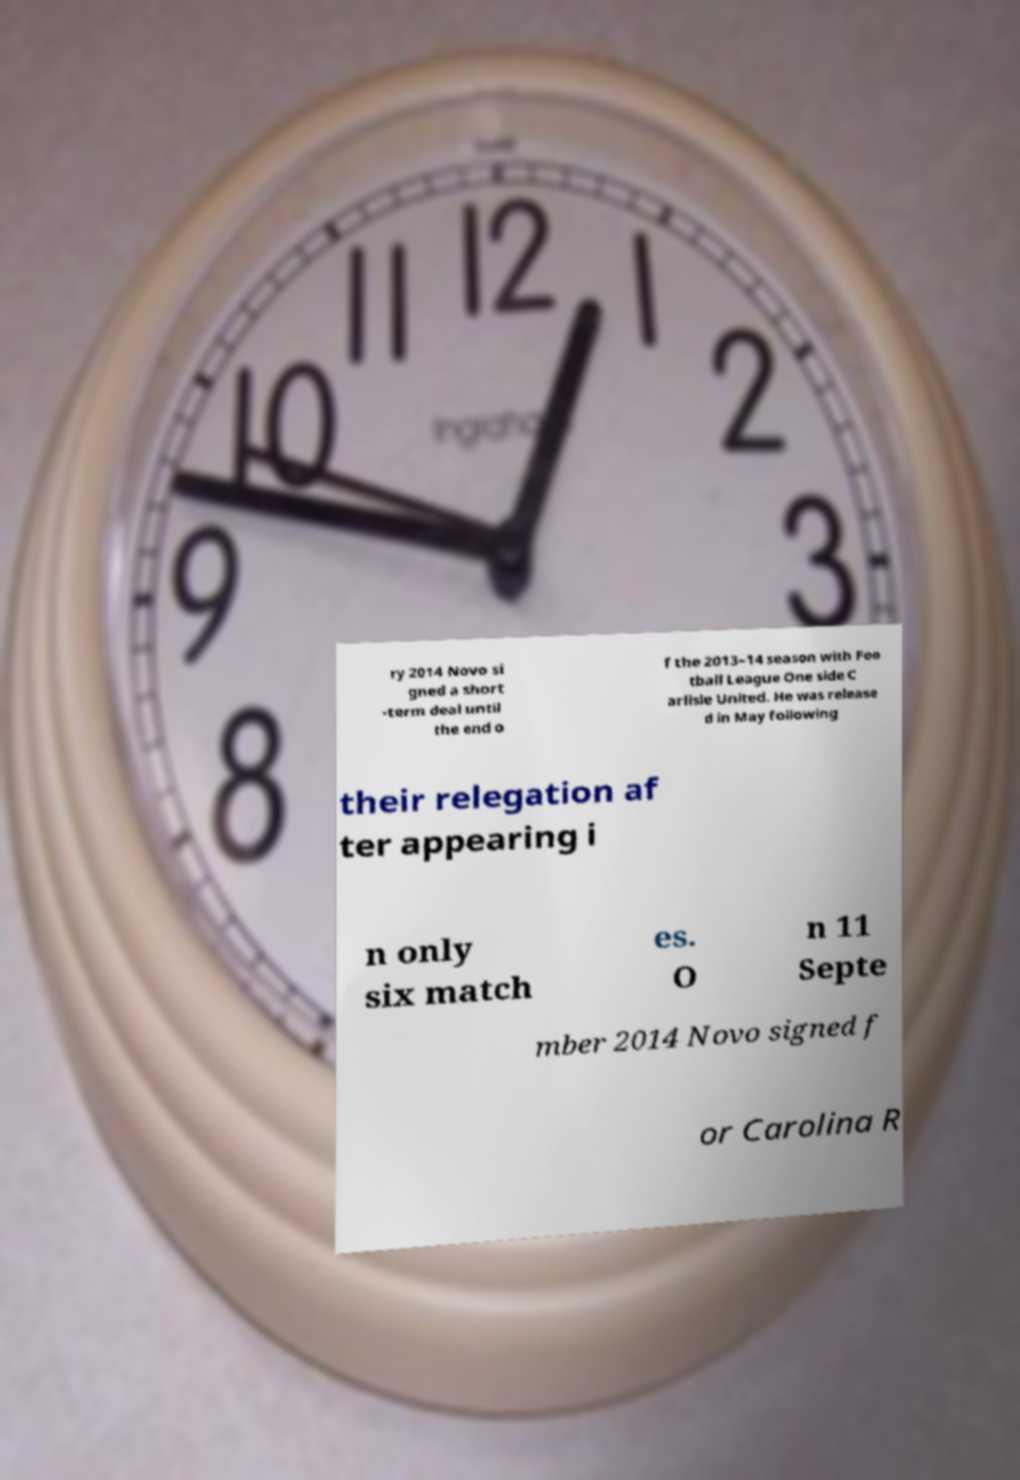Please identify and transcribe the text found in this image. ry 2014 Novo si gned a short -term deal until the end o f the 2013–14 season with Foo tball League One side C arlisle United. He was release d in May following their relegation af ter appearing i n only six match es. O n 11 Septe mber 2014 Novo signed f or Carolina R 